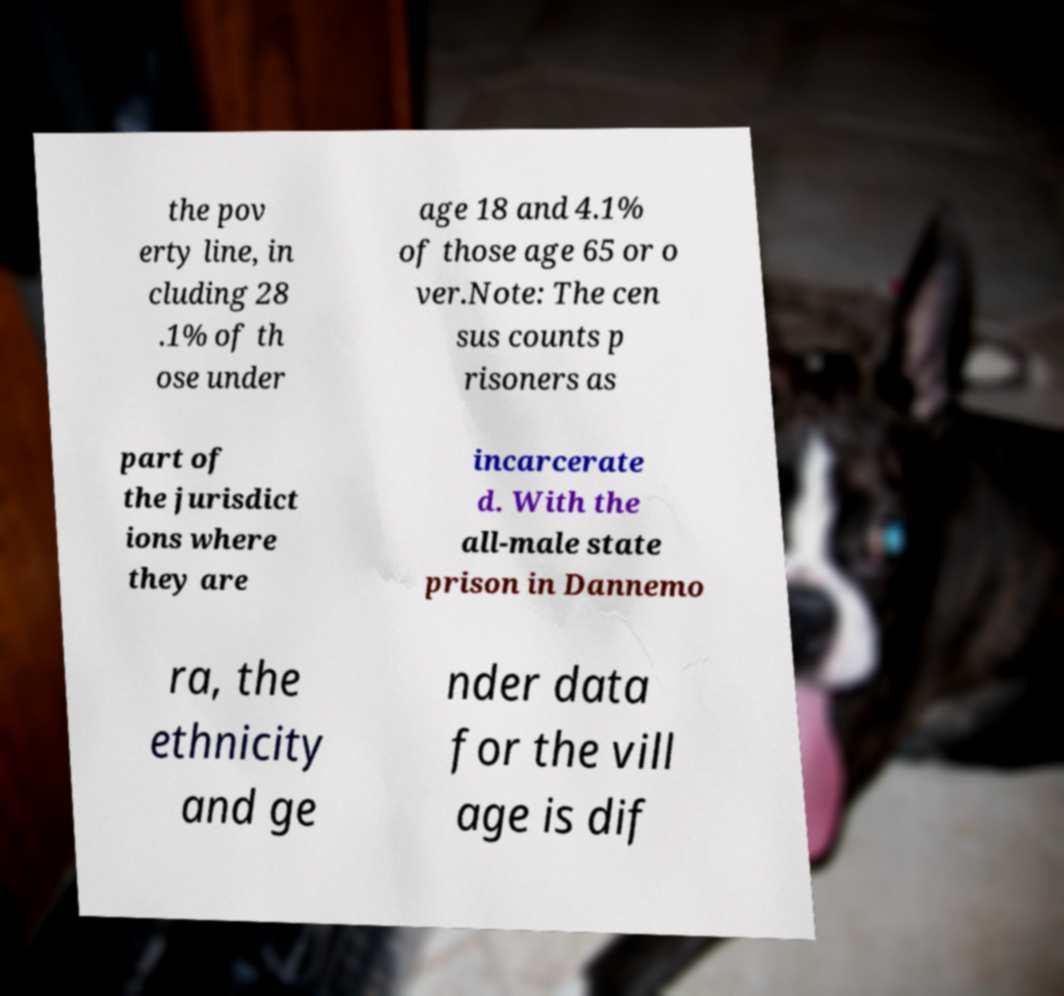For documentation purposes, I need the text within this image transcribed. Could you provide that? the pov erty line, in cluding 28 .1% of th ose under age 18 and 4.1% of those age 65 or o ver.Note: The cen sus counts p risoners as part of the jurisdict ions where they are incarcerate d. With the all-male state prison in Dannemo ra, the ethnicity and ge nder data for the vill age is dif 